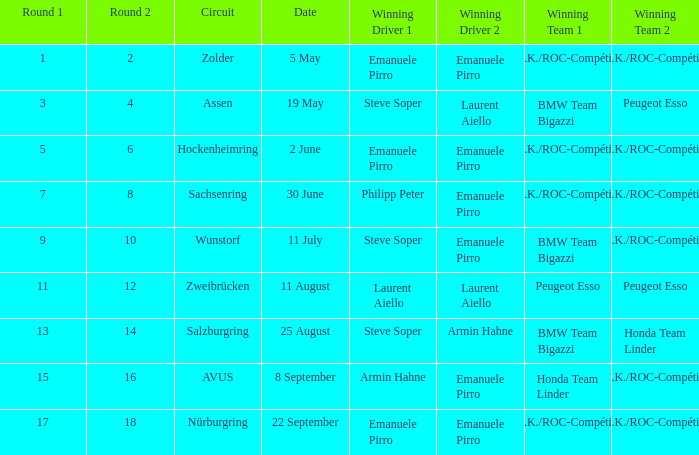What is the date of the zolder circuit, which had a.z.k./roc-compétition a.z.k./roc-compétition as the winning team? 5 May. 